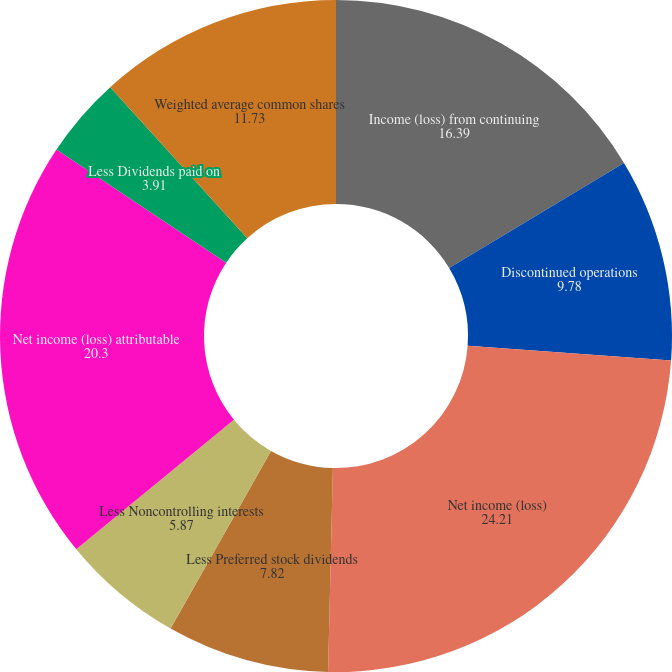<chart> <loc_0><loc_0><loc_500><loc_500><pie_chart><fcel>Income (loss) from continuing<fcel>Discontinued operations<fcel>Net income (loss)<fcel>Less Preferred stock dividends<fcel>Less Noncontrolling interests<fcel>Net income (loss) attributable<fcel>Less Dividends paid on<fcel>Weighted average common shares<nl><fcel>16.39%<fcel>9.78%<fcel>24.21%<fcel>7.82%<fcel>5.87%<fcel>20.3%<fcel>3.91%<fcel>11.73%<nl></chart> 